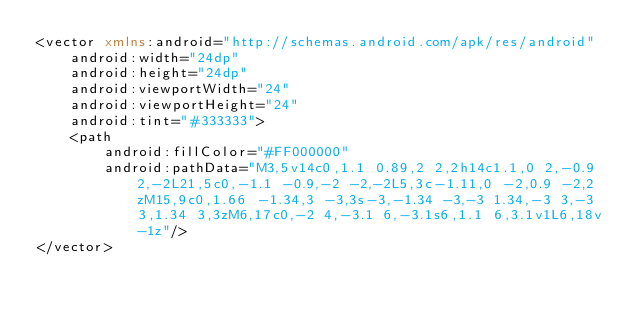Convert code to text. <code><loc_0><loc_0><loc_500><loc_500><_XML_><vector xmlns:android="http://schemas.android.com/apk/res/android"
    android:width="24dp"
    android:height="24dp"
    android:viewportWidth="24"
    android:viewportHeight="24"
    android:tint="#333333">
    <path
        android:fillColor="#FF000000"
        android:pathData="M3,5v14c0,1.1 0.89,2 2,2h14c1.1,0 2,-0.9 2,-2L21,5c0,-1.1 -0.9,-2 -2,-2L5,3c-1.11,0 -2,0.9 -2,2zM15,9c0,1.66 -1.34,3 -3,3s-3,-1.34 -3,-3 1.34,-3 3,-3 3,1.34 3,3zM6,17c0,-2 4,-3.1 6,-3.1s6,1.1 6,3.1v1L6,18v-1z"/>
</vector>
</code> 